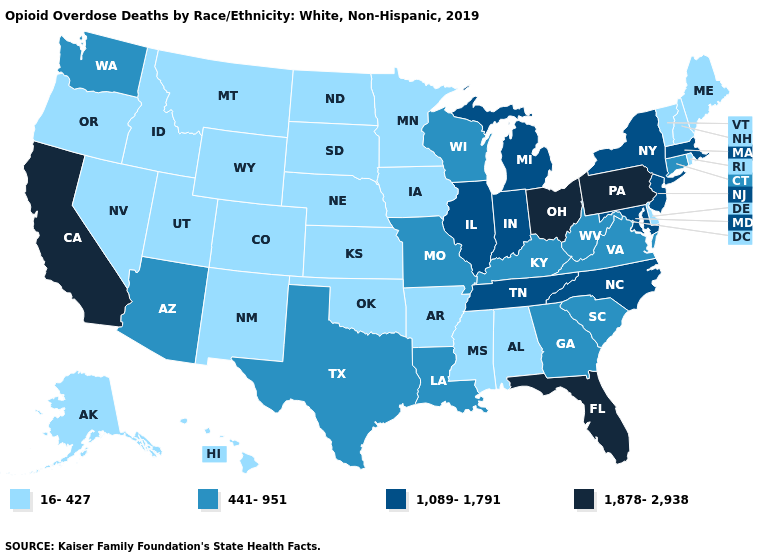Does the map have missing data?
Be succinct. No. What is the value of Oregon?
Be succinct. 16-427. What is the value of Michigan?
Give a very brief answer. 1,089-1,791. Which states hav the highest value in the MidWest?
Answer briefly. Ohio. Name the states that have a value in the range 441-951?
Keep it brief. Arizona, Connecticut, Georgia, Kentucky, Louisiana, Missouri, South Carolina, Texas, Virginia, Washington, West Virginia, Wisconsin. Does Pennsylvania have the highest value in the USA?
Answer briefly. Yes. What is the value of Nevada?
Short answer required. 16-427. What is the value of North Carolina?
Quick response, please. 1,089-1,791. What is the lowest value in the USA?
Short answer required. 16-427. Does New Mexico have the same value as California?
Short answer required. No. Does Delaware have a higher value than New Mexico?
Be succinct. No. Among the states that border Texas , which have the lowest value?
Concise answer only. Arkansas, New Mexico, Oklahoma. How many symbols are there in the legend?
Concise answer only. 4. Is the legend a continuous bar?
Answer briefly. No. 